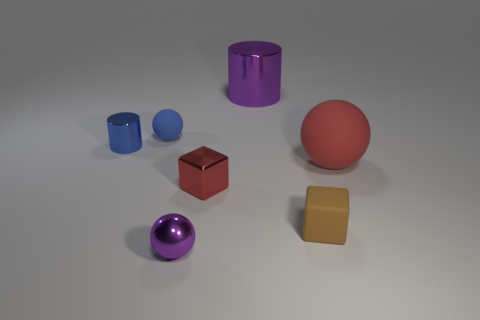Subtract 1 balls. How many balls are left? 2 Subtract all tiny spheres. How many spheres are left? 1 Add 2 big red balls. How many objects exist? 9 Subtract all cylinders. How many objects are left? 5 Subtract all small purple matte balls. Subtract all large red spheres. How many objects are left? 6 Add 1 red metal cubes. How many red metal cubes are left? 2 Add 1 tiny metallic cylinders. How many tiny metallic cylinders exist? 2 Subtract 0 green balls. How many objects are left? 7 